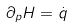<formula> <loc_0><loc_0><loc_500><loc_500>\partial _ { p } H = \dot { q }</formula> 